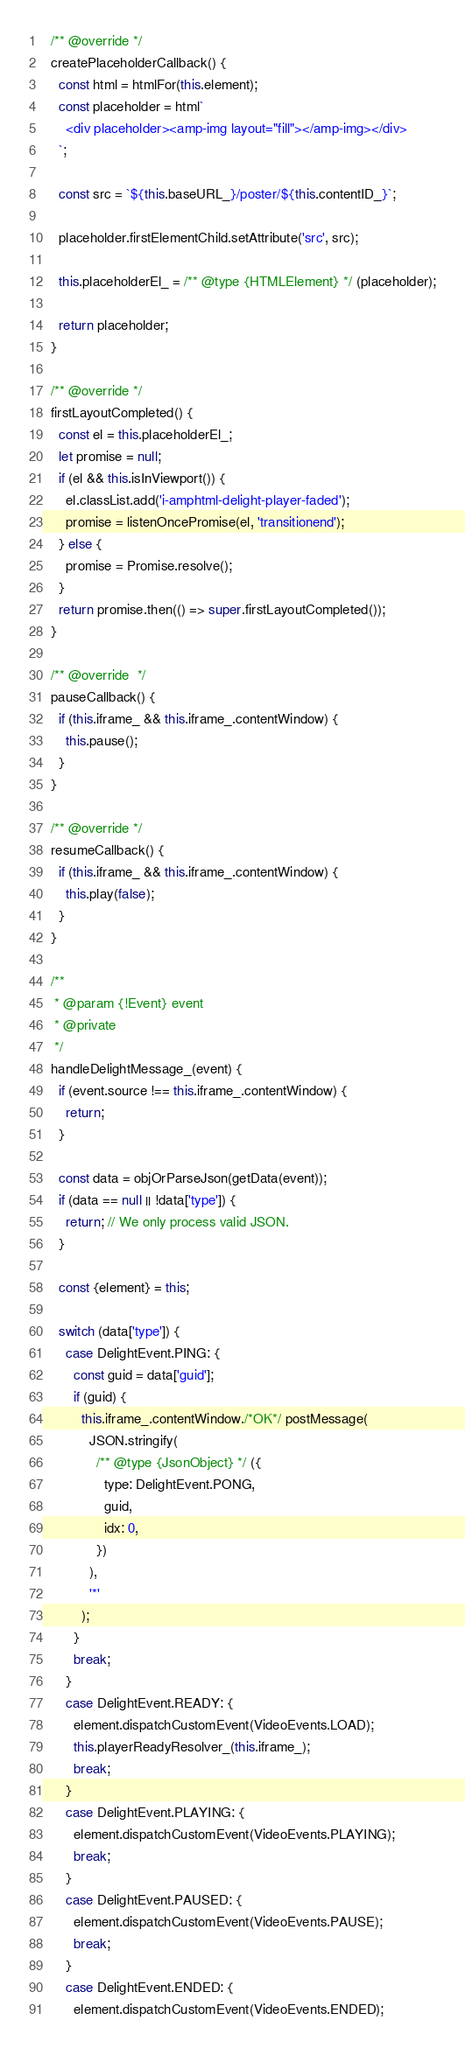Convert code to text. <code><loc_0><loc_0><loc_500><loc_500><_JavaScript_>
  /** @override */
  createPlaceholderCallback() {
    const html = htmlFor(this.element);
    const placeholder = html`
      <div placeholder><amp-img layout="fill"></amp-img></div>
    `;

    const src = `${this.baseURL_}/poster/${this.contentID_}`;

    placeholder.firstElementChild.setAttribute('src', src);

    this.placeholderEl_ = /** @type {HTMLElement} */ (placeholder);

    return placeholder;
  }

  /** @override */
  firstLayoutCompleted() {
    const el = this.placeholderEl_;
    let promise = null;
    if (el && this.isInViewport()) {
      el.classList.add('i-amphtml-delight-player-faded');
      promise = listenOncePromise(el, 'transitionend');
    } else {
      promise = Promise.resolve();
    }
    return promise.then(() => super.firstLayoutCompleted());
  }

  /** @override  */
  pauseCallback() {
    if (this.iframe_ && this.iframe_.contentWindow) {
      this.pause();
    }
  }

  /** @override */
  resumeCallback() {
    if (this.iframe_ && this.iframe_.contentWindow) {
      this.play(false);
    }
  }

  /**
   * @param {!Event} event
   * @private
   */
  handleDelightMessage_(event) {
    if (event.source !== this.iframe_.contentWindow) {
      return;
    }

    const data = objOrParseJson(getData(event));
    if (data == null || !data['type']) {
      return; // We only process valid JSON.
    }

    const {element} = this;

    switch (data['type']) {
      case DelightEvent.PING: {
        const guid = data['guid'];
        if (guid) {
          this.iframe_.contentWindow./*OK*/ postMessage(
            JSON.stringify(
              /** @type {JsonObject} */ ({
                type: DelightEvent.PONG,
                guid,
                idx: 0,
              })
            ),
            '*'
          );
        }
        break;
      }
      case DelightEvent.READY: {
        element.dispatchCustomEvent(VideoEvents.LOAD);
        this.playerReadyResolver_(this.iframe_);
        break;
      }
      case DelightEvent.PLAYING: {
        element.dispatchCustomEvent(VideoEvents.PLAYING);
        break;
      }
      case DelightEvent.PAUSED: {
        element.dispatchCustomEvent(VideoEvents.PAUSE);
        break;
      }
      case DelightEvent.ENDED: {
        element.dispatchCustomEvent(VideoEvents.ENDED);</code> 